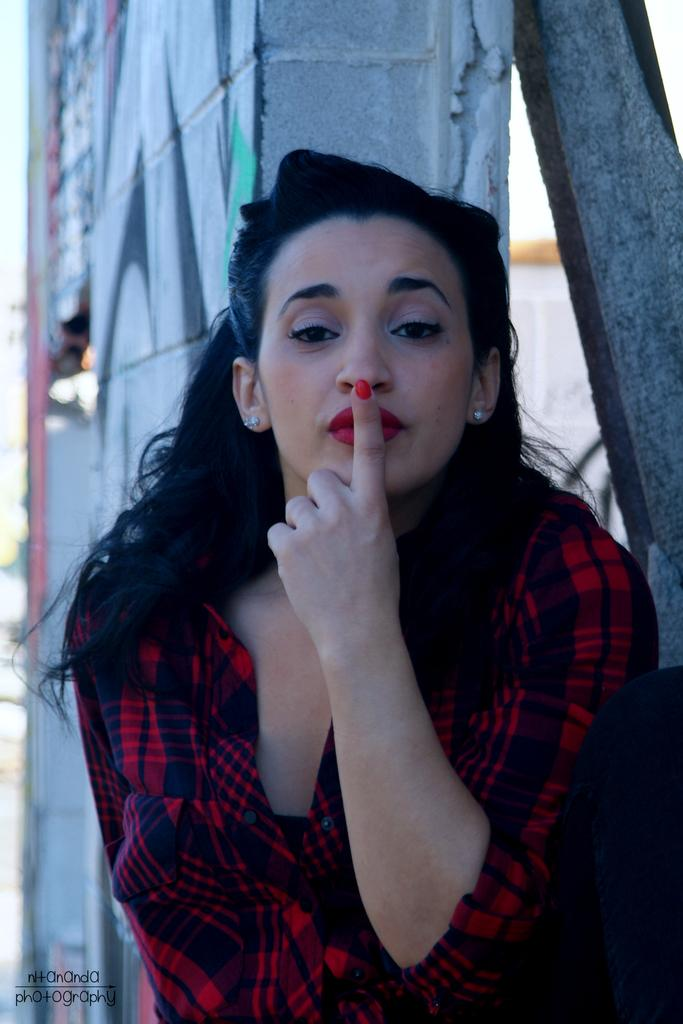Who is in the image? There is a woman in the image. What is the woman wearing? The woman is wearing a red shirt. What is the woman doing with her finger? The woman is keeping her finger on her lip. What can be seen behind the woman? There is a wall behind the woman. What type of leather material is visible on the woman's shoes in the image? There is no mention of shoes or leather in the provided facts, so we cannot determine if any leather material is visible in the image. 